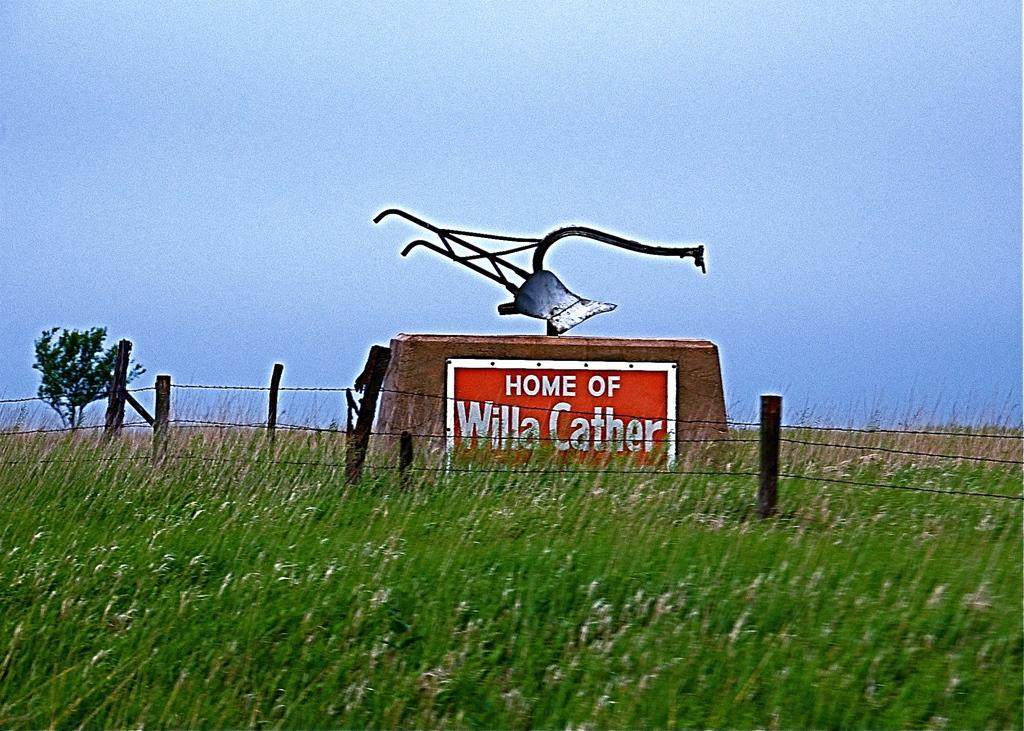What type of vegetation covers the land in the image? The land is covered with grass. Can you describe any distant objects in the image? There is a tree in the distance. What is on the wall in the image? There is a board on a wall. What is in front of the board in the image? There is a fence in front of the board. Can you see a kite flying in the image? There is no kite visible in the image. Are there any people fighting in the image? There are no people or fights depicted in the image. 